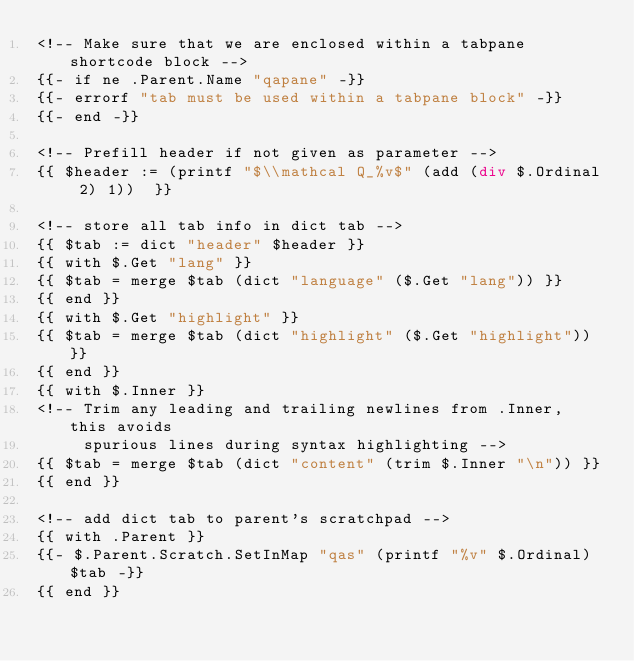Convert code to text. <code><loc_0><loc_0><loc_500><loc_500><_HTML_><!-- Make sure that we are enclosed within a tabpane shortcode block -->
{{- if ne .Parent.Name "qapane" -}}
{{- errorf "tab must be used within a tabpane block" -}}
{{- end -}}

<!-- Prefill header if not given as parameter -->
{{ $header := (printf "$\\mathcal Q_%v$" (add (div $.Ordinal 2) 1))  }}

<!-- store all tab info in dict tab -->
{{ $tab := dict "header" $header }}
{{ with $.Get "lang" }}
{{ $tab = merge $tab (dict "language" ($.Get "lang")) }}
{{ end }}
{{ with $.Get "highlight" }}
{{ $tab = merge $tab (dict "highlight" ($.Get "highlight")) }}
{{ end }}
{{ with $.Inner }}
<!-- Trim any leading and trailing newlines from .Inner, this avoids
     spurious lines during syntax highlighting -->
{{ $tab = merge $tab (dict "content" (trim $.Inner "\n")) }}
{{ end }}

<!-- add dict tab to parent's scratchpad -->
{{ with .Parent }}
{{- $.Parent.Scratch.SetInMap "qas" (printf "%v" $.Ordinal) $tab -}}
{{ end }}</code> 